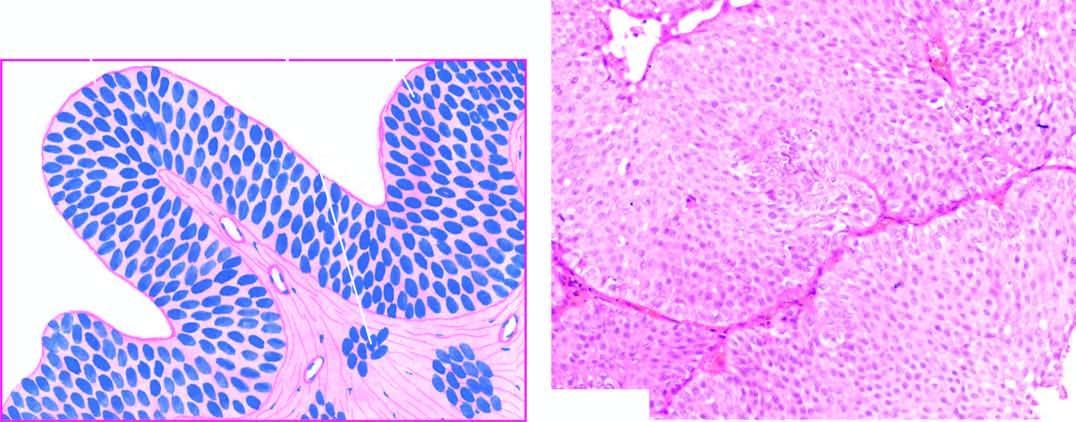s there increase in the number of layers of epithelium?
Answer the question using a single word or phrase. Yes 